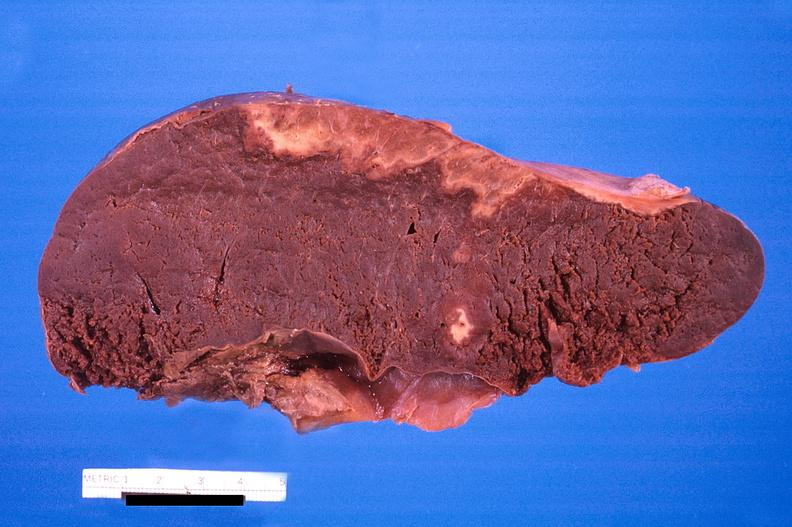what does this image show?
Answer the question using a single word or phrase. Spleen 